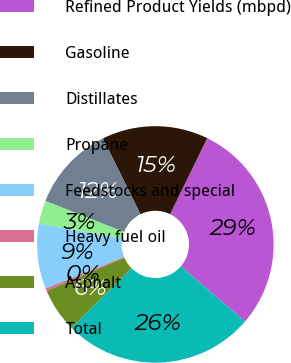<chart> <loc_0><loc_0><loc_500><loc_500><pie_chart><fcel>Refined Product Yields (mbpd)<fcel>Gasoline<fcel>Distillates<fcel>Propane<fcel>Feedstocks and special<fcel>Heavy fuel oil<fcel>Asphalt<fcel>Total<nl><fcel>29.07%<fcel>14.54%<fcel>11.71%<fcel>3.19%<fcel>8.87%<fcel>0.36%<fcel>6.03%<fcel>26.23%<nl></chart> 